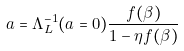Convert formula to latex. <formula><loc_0><loc_0><loc_500><loc_500>a = \Lambda _ { L } ^ { - 1 } ( a = 0 ) \frac { f ( \beta ) } { 1 - \eta f ( \beta ) }</formula> 